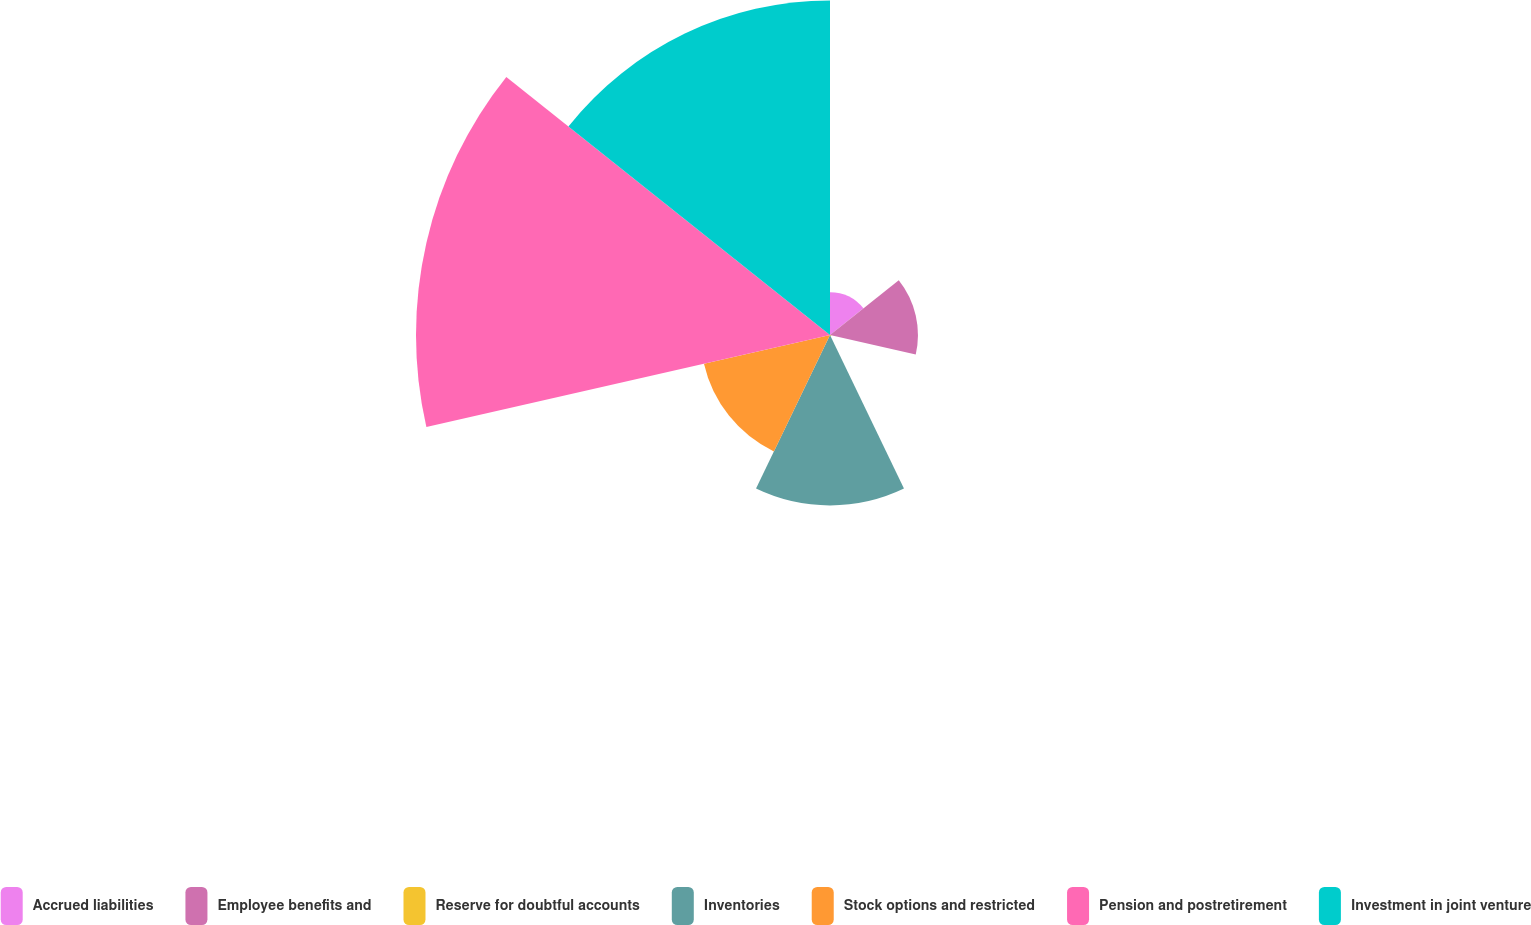Convert chart to OTSL. <chart><loc_0><loc_0><loc_500><loc_500><pie_chart><fcel>Accrued liabilities<fcel>Employee benefits and<fcel>Reserve for doubtful accounts<fcel>Inventories<fcel>Stock options and restricted<fcel>Pension and postretirement<fcel>Investment in joint venture<nl><fcel>3.62%<fcel>7.45%<fcel>0.13%<fcel>14.44%<fcel>10.95%<fcel>35.07%<fcel>28.34%<nl></chart> 